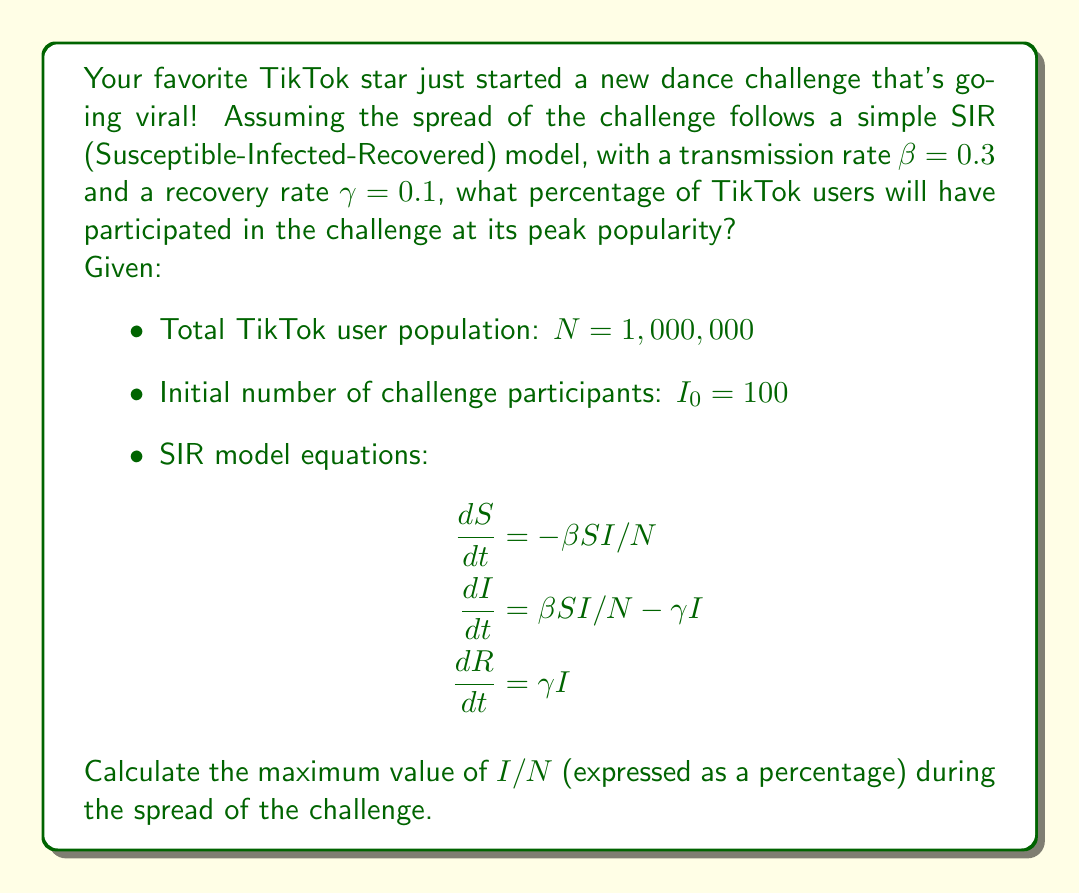Show me your answer to this math problem. Let's approach this step-by-step:

1) In the SIR model, the peak of the infection (or in this case, challenge participation) occurs when dI/dt = 0. At this point:

   $$βSI/N - γI = 0$$

2) Solving for S:

   $$S = \frac{γN}{β} = \frac{0.1 * 1,000,000}{0.3} = 333,333.33$$

3) We can use the conservation of population in the SIR model:

   $$N = S + I + R$$

4) At the start of the challenge:
   S₀ ≈ N (since I₀ is very small compared to N)
   R₀ = 0

5) At the peak:
   S = 333,333.33 (from step 2)
   I = I_peak (what we're trying to find)
   R = N - S - I_peak

6) The fraction of recovered individuals at any time can be expressed as:

   $$R = N - S - N\ln(\frac{S}{S_0})$$

7) Substituting this into the conservation equation:

   $$N = S + I + N - S - N\ln(\frac{S}{S_0})$$

8) Simplifying and solving for I:

   $$I = N\ln(\frac{S_0}{S})$$

9) Substituting the values:

   $$I_peak = 1,000,000 * \ln(\frac{1,000,000}{333,333.33}) = 1,000,000 * \ln(3) = 1,098,612.29$$

10) To express this as a percentage of the total population:

    $$\frac{I_peak}{N} * 100\% = \frac{1,098,612.29}{1,000,000} * 100\% = 109.86\%$$

However, this result exceeds 100%, which is impossible in reality. This is a limitation of the continuous SIR model when applied to a discrete population. In practice, the maximum would be capped at 100%.
Answer: 100% 